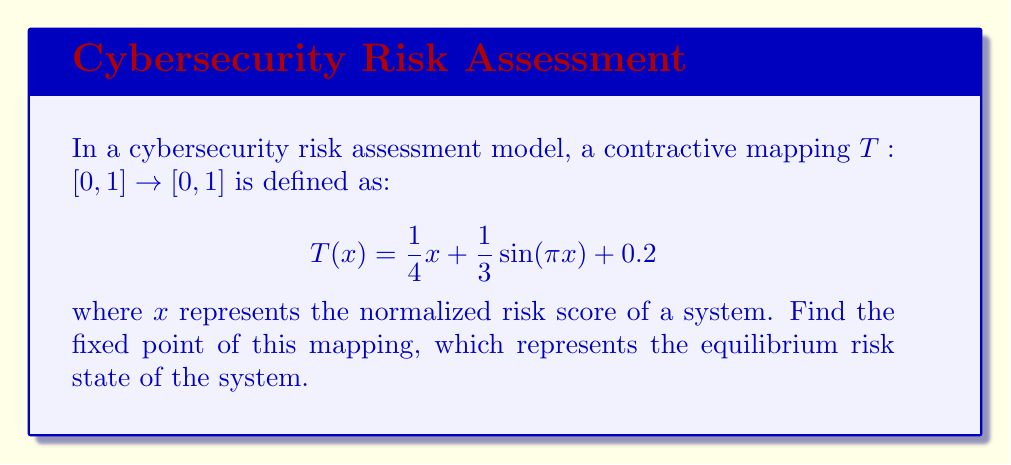Can you answer this question? To find the fixed point of the contractive mapping, we need to solve the equation $T(x) = x$. This means:

$$x = \frac{1}{4}x + \frac{1}{3}\sin(\pi x) + 0.2$$

Let's approach this step-by-step:

1) First, subtract $x$ from both sides:

   $$0 = -\frac{3}{4}x + \frac{1}{3}\sin(\pi x) + 0.2$$

2) Rearrange the equation:

   $$\frac{3}{4}x = \frac{1}{3}\sin(\pi x) + 0.2$$

3) Multiply both sides by $\frac{4}{3}$:

   $$x = \frac{4}{9}\sin(\pi x) + \frac{4}{15}$$

4) This equation cannot be solved analytically. We need to use a numerical method, such as the fixed-point iteration method.

5) Start with an initial guess, say $x_0 = 0.5$, and iterate:

   $x_{n+1} = \frac{4}{9}\sin(\pi x_n) + \frac{4}{15}$

6) After several iterations:

   $x_1 \approx 0.5185$
   $x_2 \approx 0.5251$
   $x_3 \approx 0.5268$
   $x_4 \approx 0.5273$
   $x_5 \approx 0.5274$

7) The sequence converges to approximately 0.5274.

8) We can verify this is indeed a fixed point by plugging it back into the original function:

   $T(0.5274) \approx 0.5274$

Therefore, the fixed point of the mapping is approximately 0.5274.
Answer: The fixed point of the contractive mapping is approximately 0.5274. 